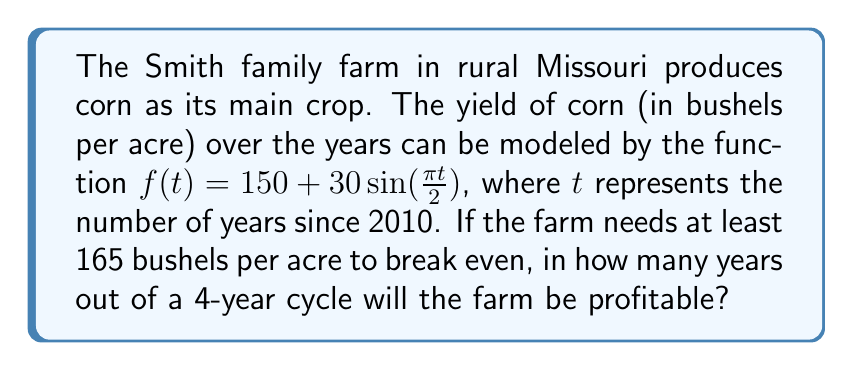Could you help me with this problem? Let's approach this step-by-step:

1) The function $f(t) = 150 + 30\sin(\frac{\pi t}{2})$ represents the corn yield in bushels per acre.

2) The farm needs at least 165 bushels per acre to break even. So, we need to find when $f(t) \geq 165$.

3) Let's set up the inequality:
   $150 + 30\sin(\frac{\pi t}{2}) \geq 165$

4) Subtract 150 from both sides:
   $30\sin(\frac{\pi t}{2}) \geq 15$

5) Divide both sides by 30:
   $\sin(\frac{\pi t}{2}) \geq 0.5$

6) To solve this, we need to find the inverse sine (arcsin) of 0.5:
   $\frac{\pi t}{2} \geq \arcsin(0.5) \approx 0.5236$ radians

7) Multiply both sides by $\frac{2}{\pi}$:
   $t \geq \frac{2}{\pi} \cdot 0.5236 \approx 0.3333$ years

8) The function has a period of 4 years (because $\sin(\frac{\pi t}{2})$ completes a full cycle when $\frac{\pi t}{2} = 2\pi$, or when $t = 4$).

9) In each 4-year cycle, the farm is profitable from $t \approx 0.3333$ to $t \approx 3.6667$ (which is 4 - 0.3333).

10) This means the farm is profitable for approximately 3.3334 years out of every 4-year cycle.

11) Rounding to the nearest whole number (as we're asked for the number of years), we get 3 years.
Answer: 3 years 